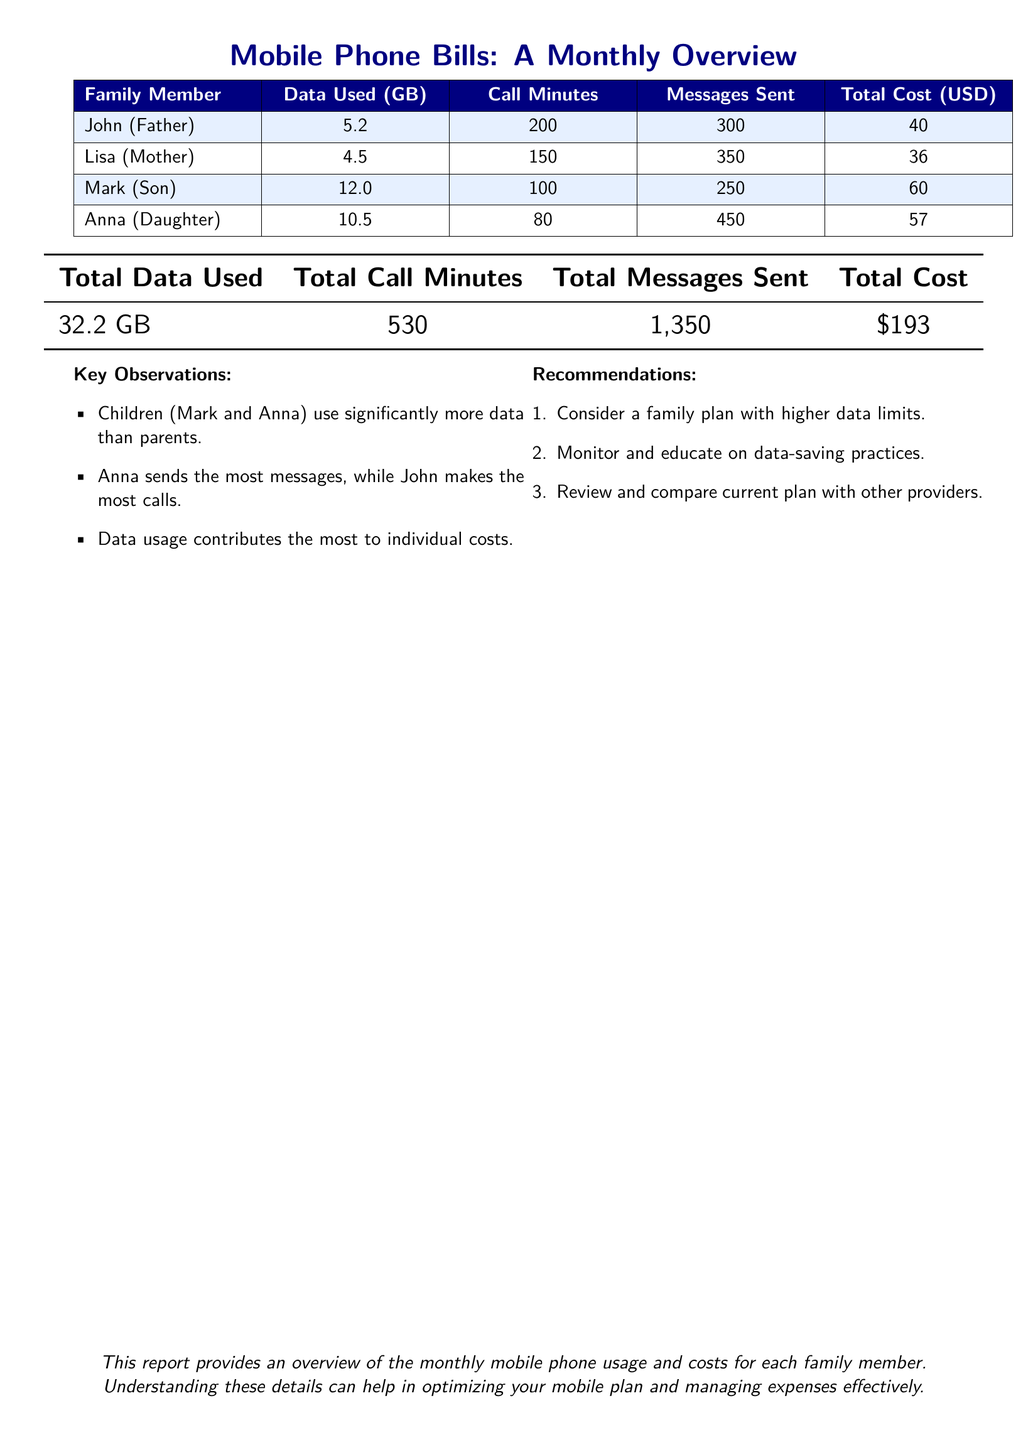What is the total data used by the family? The total data used by the family is calculated by adding the data used by each family member, resulting in 32.2 GB.
Answer: 32.2 GB Who used the most data? Mark, the son, has the highest data usage at 12.0 GB among all family members.
Answer: Mark What is Lisa's total cost? The total cost associated with Lisa's mobile usage is specified in the document as $36.
Answer: $36 Which family member sent the most messages? Anna has sent the highest number of messages, which totals 450.
Answer: Anna What is the total number of call minutes used by the family? The total call minutes used by all family members is the sum of their individual minutes, equaling 530.
Answer: 530 What recommendation is given regarding the data plan? One of the recommendations includes considering a family plan with higher data limits to better accommodate usage.
Answer: Higher data limits How many call minutes did John use? John made a total of 200 call minutes during the month as noted in the report.
Answer: 200 What is the total cost for the month? The total cost for all family members' mobile usage combined is presented as $193.
Answer: $193 